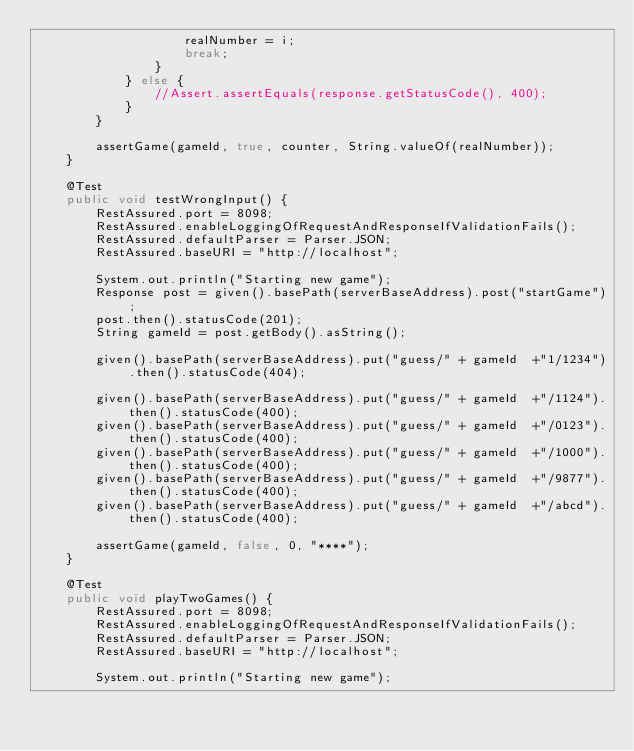Convert code to text. <code><loc_0><loc_0><loc_500><loc_500><_Java_>					realNumber = i;
					break;
				}
			} else {
				//Assert.assertEquals(response.getStatusCode(), 400);
			}
		}
		
		assertGame(gameId, true, counter, String.valueOf(realNumber));
	}

	@Test
	public void testWrongInput() {
		RestAssured.port = 8098;
		RestAssured.enableLoggingOfRequestAndResponseIfValidationFails();
		RestAssured.defaultParser = Parser.JSON;
		RestAssured.baseURI = "http://localhost";
		
		System.out.println("Starting new game");
		Response post = given().basePath(serverBaseAddress).post("startGame");
		post.then().statusCode(201);
		String gameId = post.getBody().asString();
		
		given().basePath(serverBaseAddress).put("guess/" + gameId  +"1/1234").then().statusCode(404);
		
		given().basePath(serverBaseAddress).put("guess/" + gameId  +"/1124").then().statusCode(400);
		given().basePath(serverBaseAddress).put("guess/" + gameId  +"/0123").then().statusCode(400);
		given().basePath(serverBaseAddress).put("guess/" + gameId  +"/1000").then().statusCode(400);
		given().basePath(serverBaseAddress).put("guess/" + gameId  +"/9877").then().statusCode(400);
		given().basePath(serverBaseAddress).put("guess/" + gameId  +"/abcd").then().statusCode(400);
		
		assertGame(gameId, false, 0, "****");
	}
	
	@Test
	public void playTwoGames() {
		RestAssured.port = 8098;
		RestAssured.enableLoggingOfRequestAndResponseIfValidationFails();
		RestAssured.defaultParser = Parser.JSON;
		RestAssured.baseURI = "http://localhost";
		
		System.out.println("Starting new game");</code> 